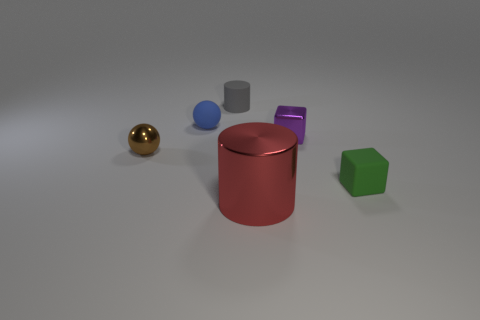Add 3 tiny yellow metallic blocks. How many objects exist? 9 Subtract all cylinders. How many objects are left? 4 Add 6 big red objects. How many big red objects are left? 7 Add 1 tiny cylinders. How many tiny cylinders exist? 2 Subtract 0 blue blocks. How many objects are left? 6 Subtract all brown metal cylinders. Subtract all purple metallic cubes. How many objects are left? 5 